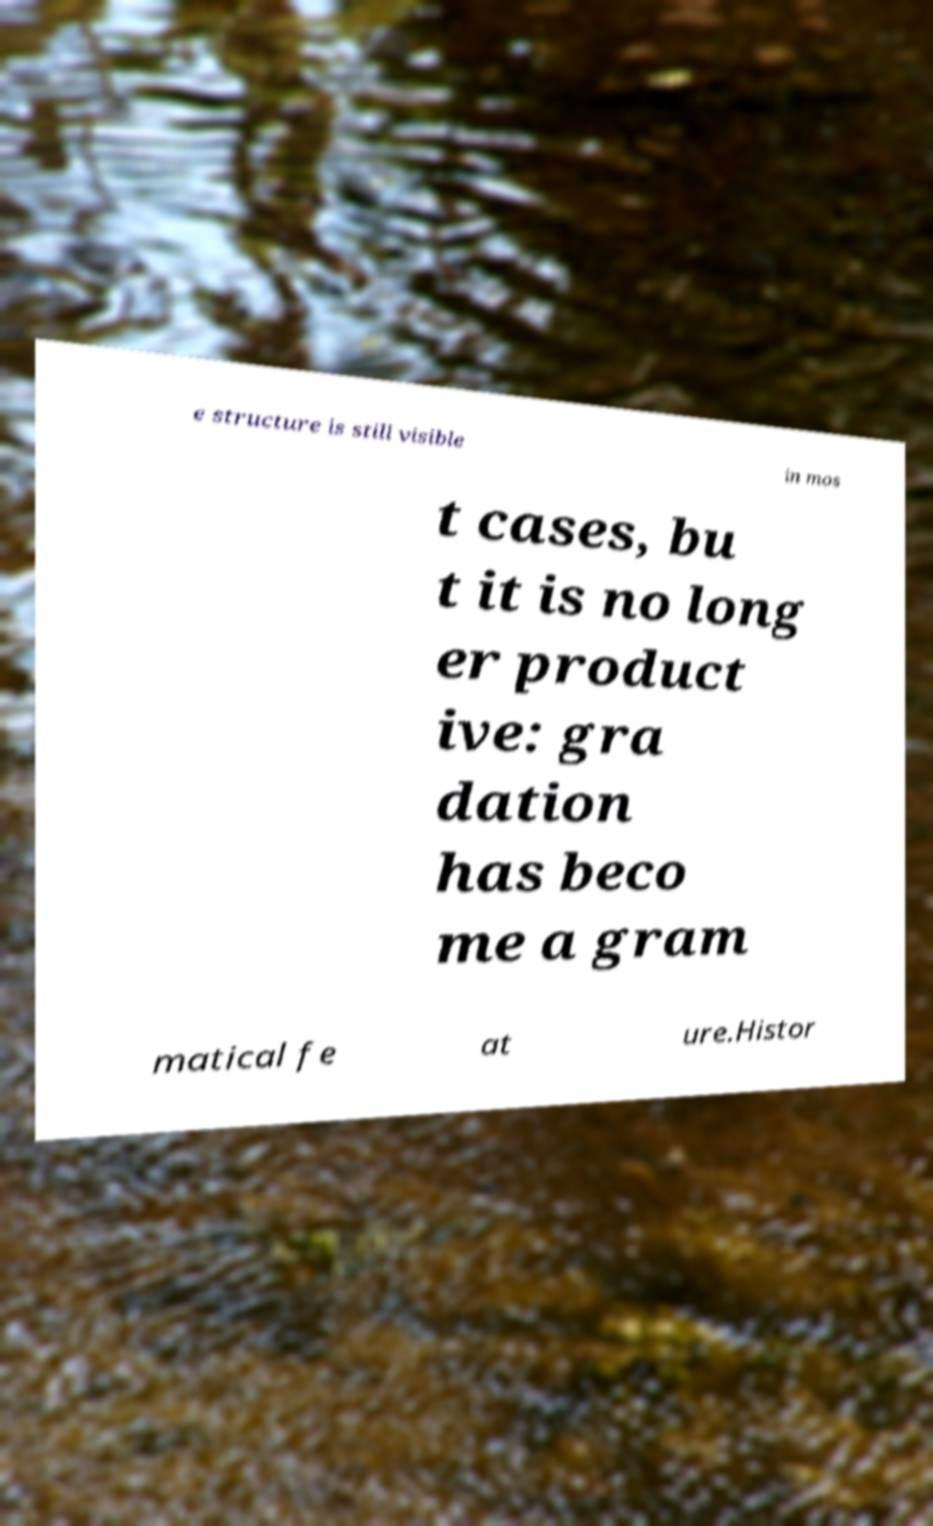Can you accurately transcribe the text from the provided image for me? e structure is still visible in mos t cases, bu t it is no long er product ive: gra dation has beco me a gram matical fe at ure.Histor 